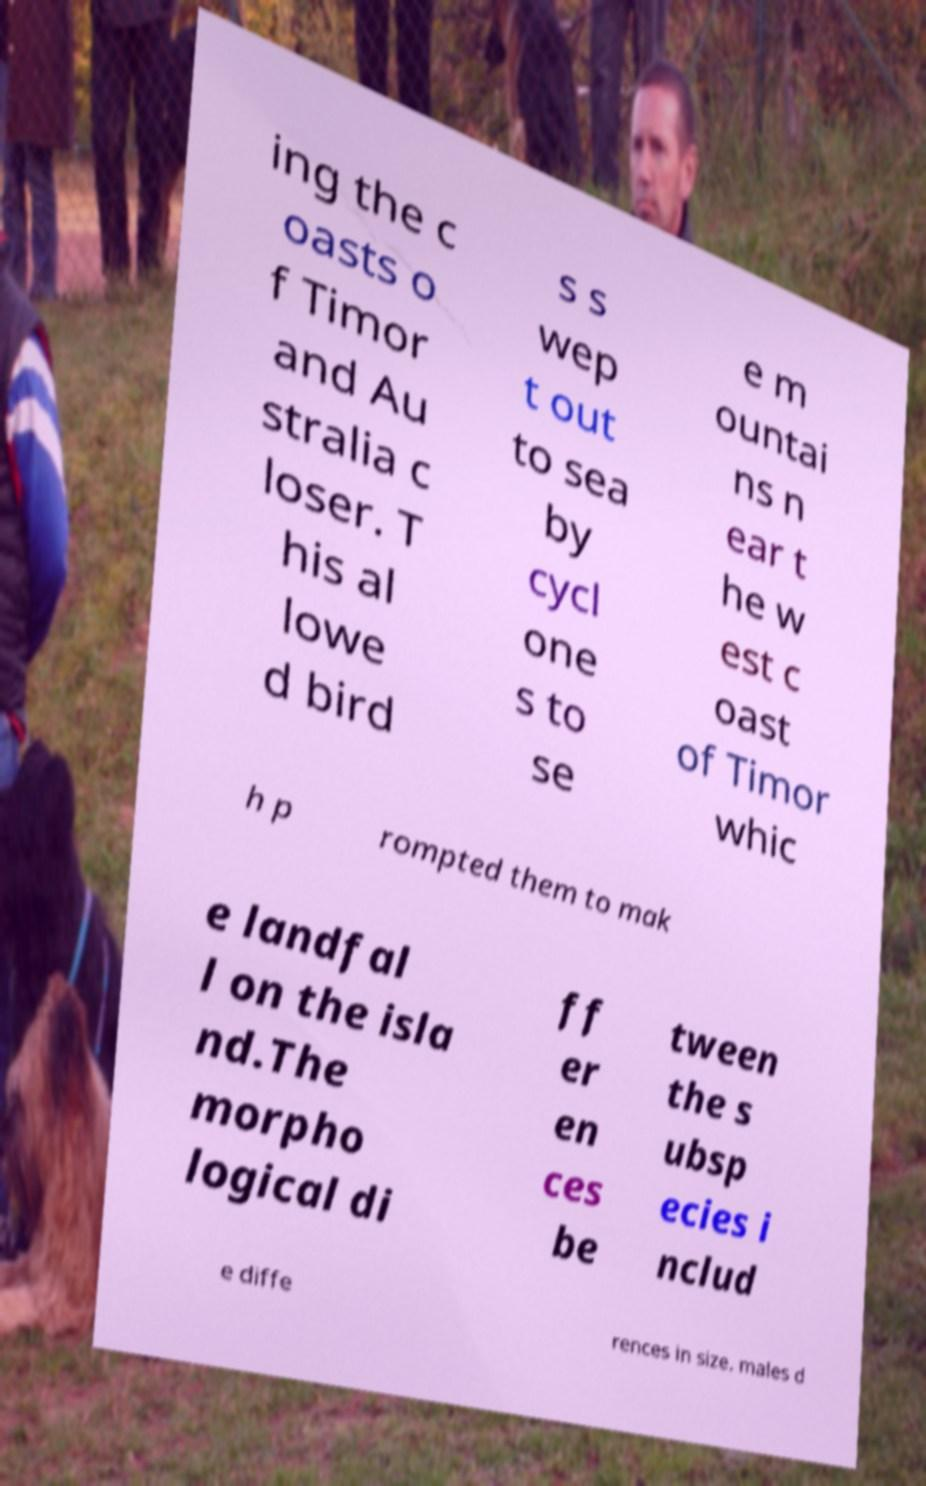I need the written content from this picture converted into text. Can you do that? ing the c oasts o f Timor and Au stralia c loser. T his al lowe d bird s s wep t out to sea by cycl one s to se e m ountai ns n ear t he w est c oast of Timor whic h p rompted them to mak e landfal l on the isla nd.The morpho logical di ff er en ces be tween the s ubsp ecies i nclud e diffe rences in size. males d 